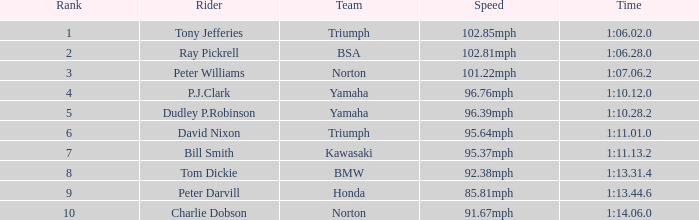Which Rider has a 1:06.02.0 Time? Tony Jefferies. 